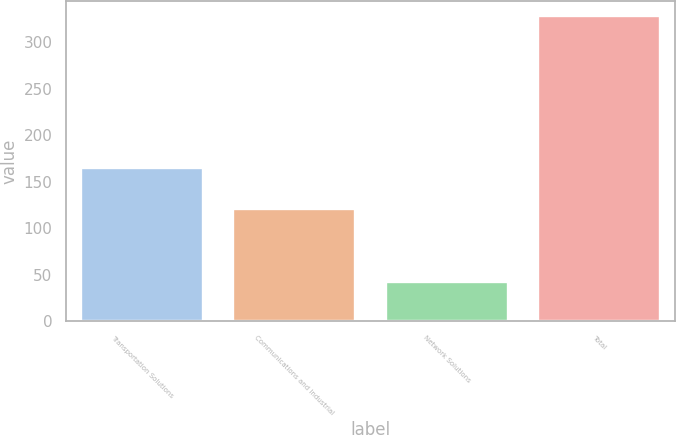Convert chart. <chart><loc_0><loc_0><loc_500><loc_500><bar_chart><fcel>Transportation Solutions<fcel>Communications and Industrial<fcel>Network Solutions<fcel>Total<nl><fcel>165<fcel>121<fcel>42<fcel>328<nl></chart> 